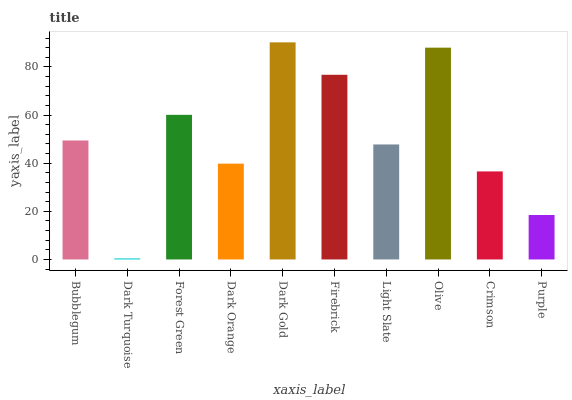Is Dark Turquoise the minimum?
Answer yes or no. Yes. Is Dark Gold the maximum?
Answer yes or no. Yes. Is Forest Green the minimum?
Answer yes or no. No. Is Forest Green the maximum?
Answer yes or no. No. Is Forest Green greater than Dark Turquoise?
Answer yes or no. Yes. Is Dark Turquoise less than Forest Green?
Answer yes or no. Yes. Is Dark Turquoise greater than Forest Green?
Answer yes or no. No. Is Forest Green less than Dark Turquoise?
Answer yes or no. No. Is Bubblegum the high median?
Answer yes or no. Yes. Is Light Slate the low median?
Answer yes or no. Yes. Is Dark Turquoise the high median?
Answer yes or no. No. Is Bubblegum the low median?
Answer yes or no. No. 